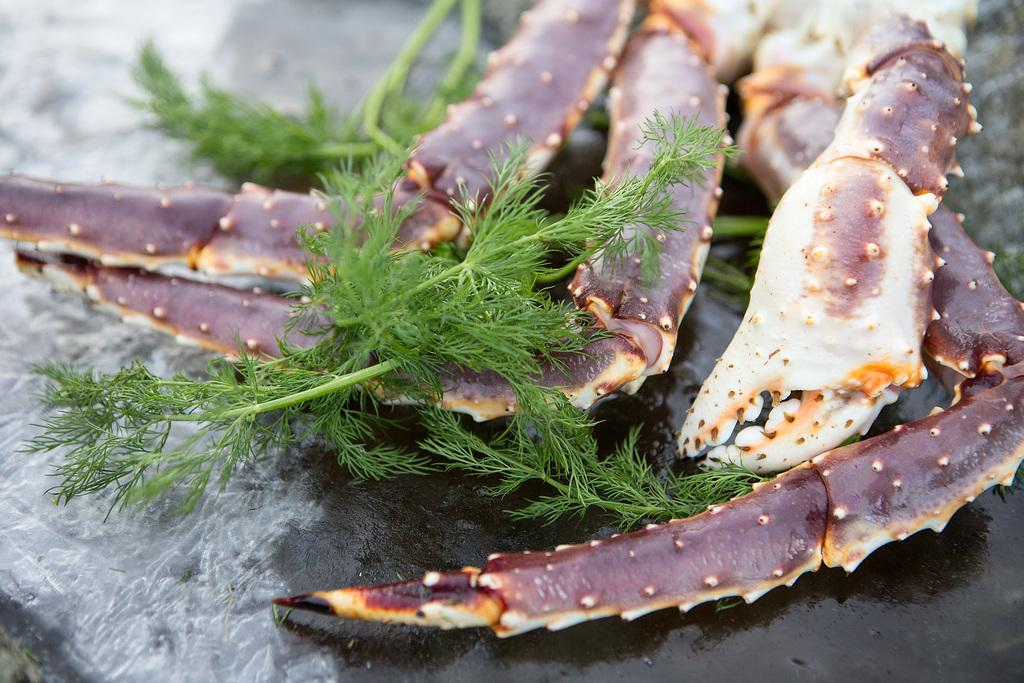What type of animal is in the image? There is a crab in the image. What type of vegetation is in the image? There are soya leaves in the image. Where are the crab and soya leaves located? Both the crab and soya leaves are on a table. When was the image taken? The image was taken during the day. What type of knee injury can be seen on the crab in the image? There is no knee injury present on the crab in the image, as crabs do not have knees. What type of wave can be seen in the image? There is no wave present in the image; it features a crab and soya leaves on a table. 